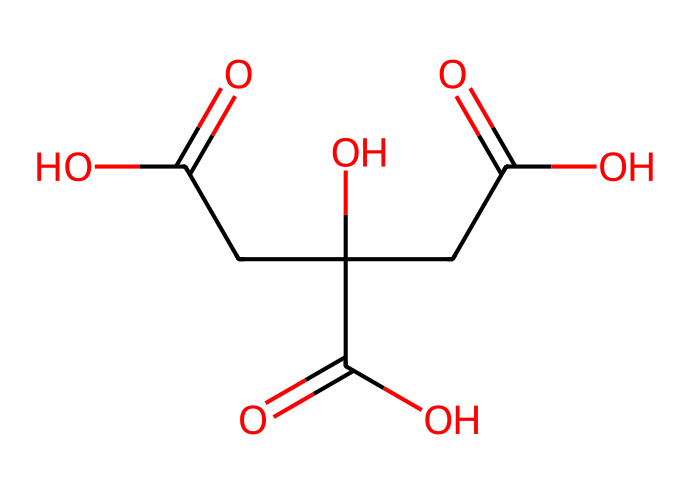how many carboxylic acid groups are present in citric acid? The structure of citric acid contains three carboxylic acid groups, identifiable as -COOH functional groups. Each is represented in the SMILES notation as part of the overall molecular structure.
Answer: three what is the molecular formula of citric acid? By analyzing the structure and counting the constituent atoms represented in the SMILES line, the molecular formula can be derived as C6H8O7.
Answer: C6H8O7 how many hydroxyl groups are in citric acid? In addition to the carboxylic acid groups, the structure shows one hydroxyl (-OH) group in the molecule. This can be identified in the SMILES string where the “O” is attached to a carbon.
Answer: one which bond type is mainly responsible for the acidic properties of citric acid? The acidic properties arise primarily from the presence of the O-H bonds in the -COOH groups. These bonds allow for hydrogen ion (H+) release, contributing to acidity.
Answer: O-H what type of organic compound is citric acid categorized as? Given that citric acid has multiple carboxylic acid functional groups and reacts as a proton donor, it is classified as a weak organic acid.
Answer: weak organic acid how many total atoms are in citric acid? By summing the total number of carbon, hydrogen, and oxygen atoms based on the molecular formula (C6H8O7), you arrive at a total of 21 atoms (6+8+7).
Answer: 21 which part of the molecule is responsible for chelating metal ions in cleaning solutions? The three carboxylic acid groups (-COOH) in the citric acid structure can bind to metal ions, making it effective in cleaning applications, particularly for delicate fabrics.
Answer: carboxylic acid groups 